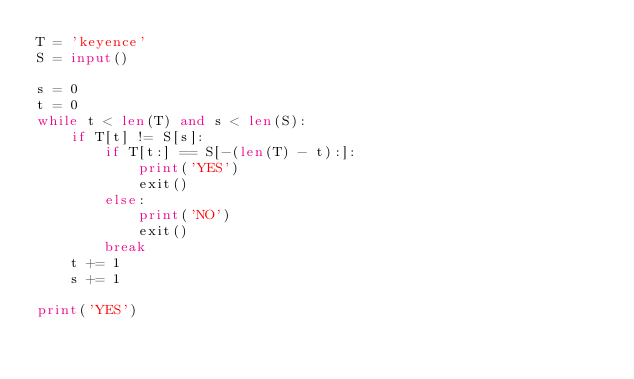Convert code to text. <code><loc_0><loc_0><loc_500><loc_500><_Python_>T = 'keyence'
S = input()

s = 0
t = 0
while t < len(T) and s < len(S):
    if T[t] != S[s]:
        if T[t:] == S[-(len(T) - t):]:
            print('YES')
            exit()
        else:
            print('NO')
            exit()
        break
    t += 1
    s += 1

print('YES')
</code> 